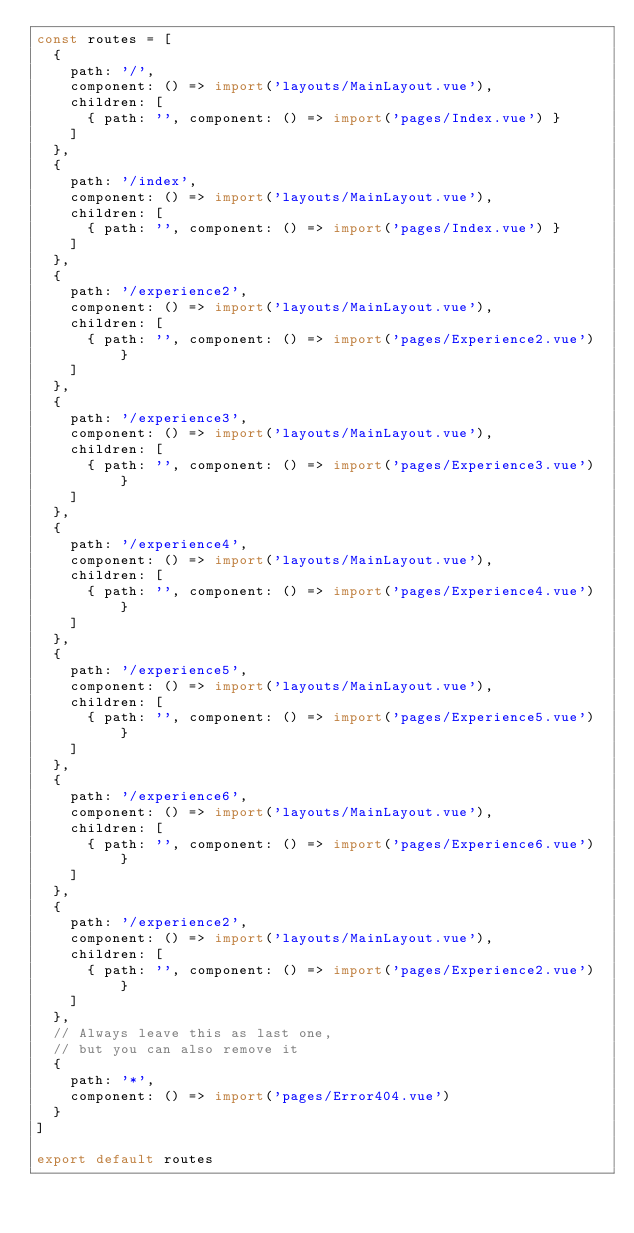Convert code to text. <code><loc_0><loc_0><loc_500><loc_500><_JavaScript_>const routes = [
  {
    path: '/',
    component: () => import('layouts/MainLayout.vue'),
    children: [
      { path: '', component: () => import('pages/Index.vue') }
    ]
  },
  {
    path: '/index',
    component: () => import('layouts/MainLayout.vue'),
    children: [
      { path: '', component: () => import('pages/Index.vue') }
    ]
  },
  {
    path: '/experience2',
    component: () => import('layouts/MainLayout.vue'),
    children: [
      { path: '', component: () => import('pages/Experience2.vue') }
    ]
  },
  {
    path: '/experience3',
    component: () => import('layouts/MainLayout.vue'),
    children: [
      { path: '', component: () => import('pages/Experience3.vue') }
    ]
  },
  {
    path: '/experience4',
    component: () => import('layouts/MainLayout.vue'),
    children: [
      { path: '', component: () => import('pages/Experience4.vue') }
    ]
  },
  {
    path: '/experience5',
    component: () => import('layouts/MainLayout.vue'),
    children: [
      { path: '', component: () => import('pages/Experience5.vue') }
    ]
  },
  {
    path: '/experience6',
    component: () => import('layouts/MainLayout.vue'),
    children: [
      { path: '', component: () => import('pages/Experience6.vue') }
    ]
  },
  {
    path: '/experience2',
    component: () => import('layouts/MainLayout.vue'),
    children: [
      { path: '', component: () => import('pages/Experience2.vue') }
    ]
  },
  // Always leave this as last one,
  // but you can also remove it
  {
    path: '*',
    component: () => import('pages/Error404.vue')
  }
]

export default routes
</code> 